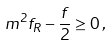<formula> <loc_0><loc_0><loc_500><loc_500>m ^ { 2 } f _ { R } - \frac { f } { 2 } \geq 0 \, ,</formula> 